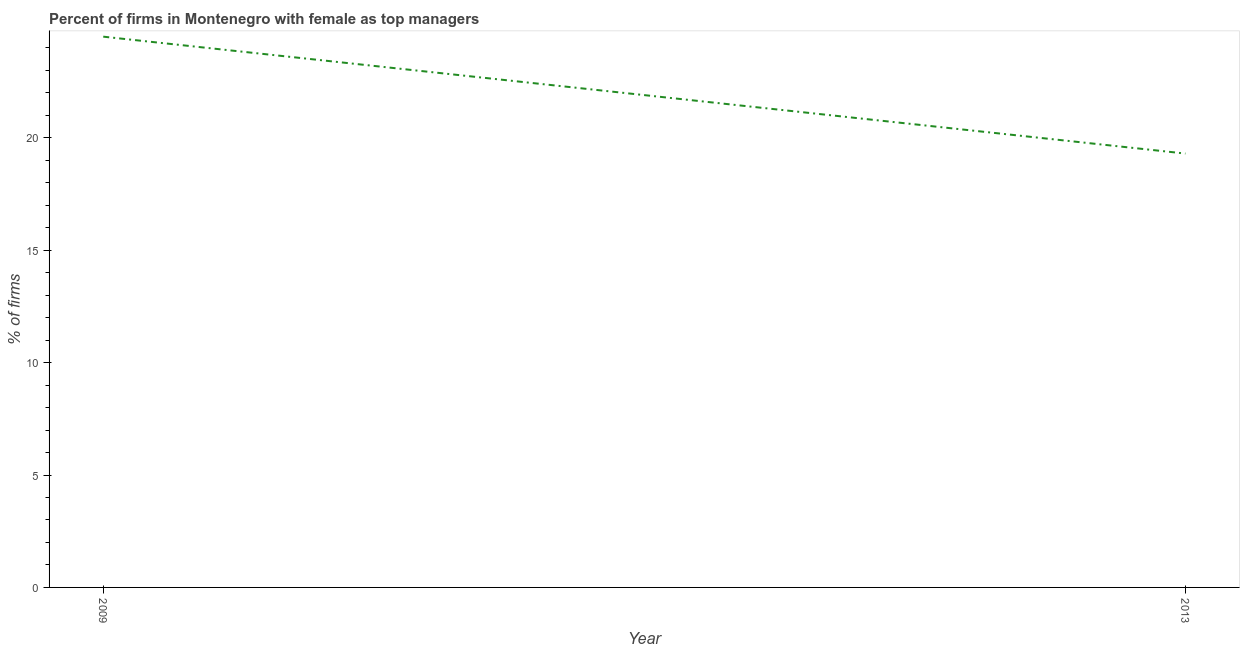Across all years, what is the maximum percentage of firms with female as top manager?
Keep it short and to the point. 24.5. Across all years, what is the minimum percentage of firms with female as top manager?
Offer a very short reply. 19.3. In which year was the percentage of firms with female as top manager maximum?
Your answer should be very brief. 2009. In which year was the percentage of firms with female as top manager minimum?
Your response must be concise. 2013. What is the sum of the percentage of firms with female as top manager?
Offer a terse response. 43.8. What is the difference between the percentage of firms with female as top manager in 2009 and 2013?
Offer a terse response. 5.2. What is the average percentage of firms with female as top manager per year?
Provide a short and direct response. 21.9. What is the median percentage of firms with female as top manager?
Offer a very short reply. 21.9. In how many years, is the percentage of firms with female as top manager greater than 4 %?
Give a very brief answer. 2. What is the ratio of the percentage of firms with female as top manager in 2009 to that in 2013?
Offer a terse response. 1.27. In how many years, is the percentage of firms with female as top manager greater than the average percentage of firms with female as top manager taken over all years?
Your answer should be compact. 1. How many lines are there?
Provide a succinct answer. 1. Are the values on the major ticks of Y-axis written in scientific E-notation?
Offer a terse response. No. Does the graph contain any zero values?
Your answer should be compact. No. What is the title of the graph?
Your answer should be compact. Percent of firms in Montenegro with female as top managers. What is the label or title of the Y-axis?
Ensure brevity in your answer.  % of firms. What is the % of firms in 2013?
Keep it short and to the point. 19.3. What is the difference between the % of firms in 2009 and 2013?
Ensure brevity in your answer.  5.2. What is the ratio of the % of firms in 2009 to that in 2013?
Provide a short and direct response. 1.27. 